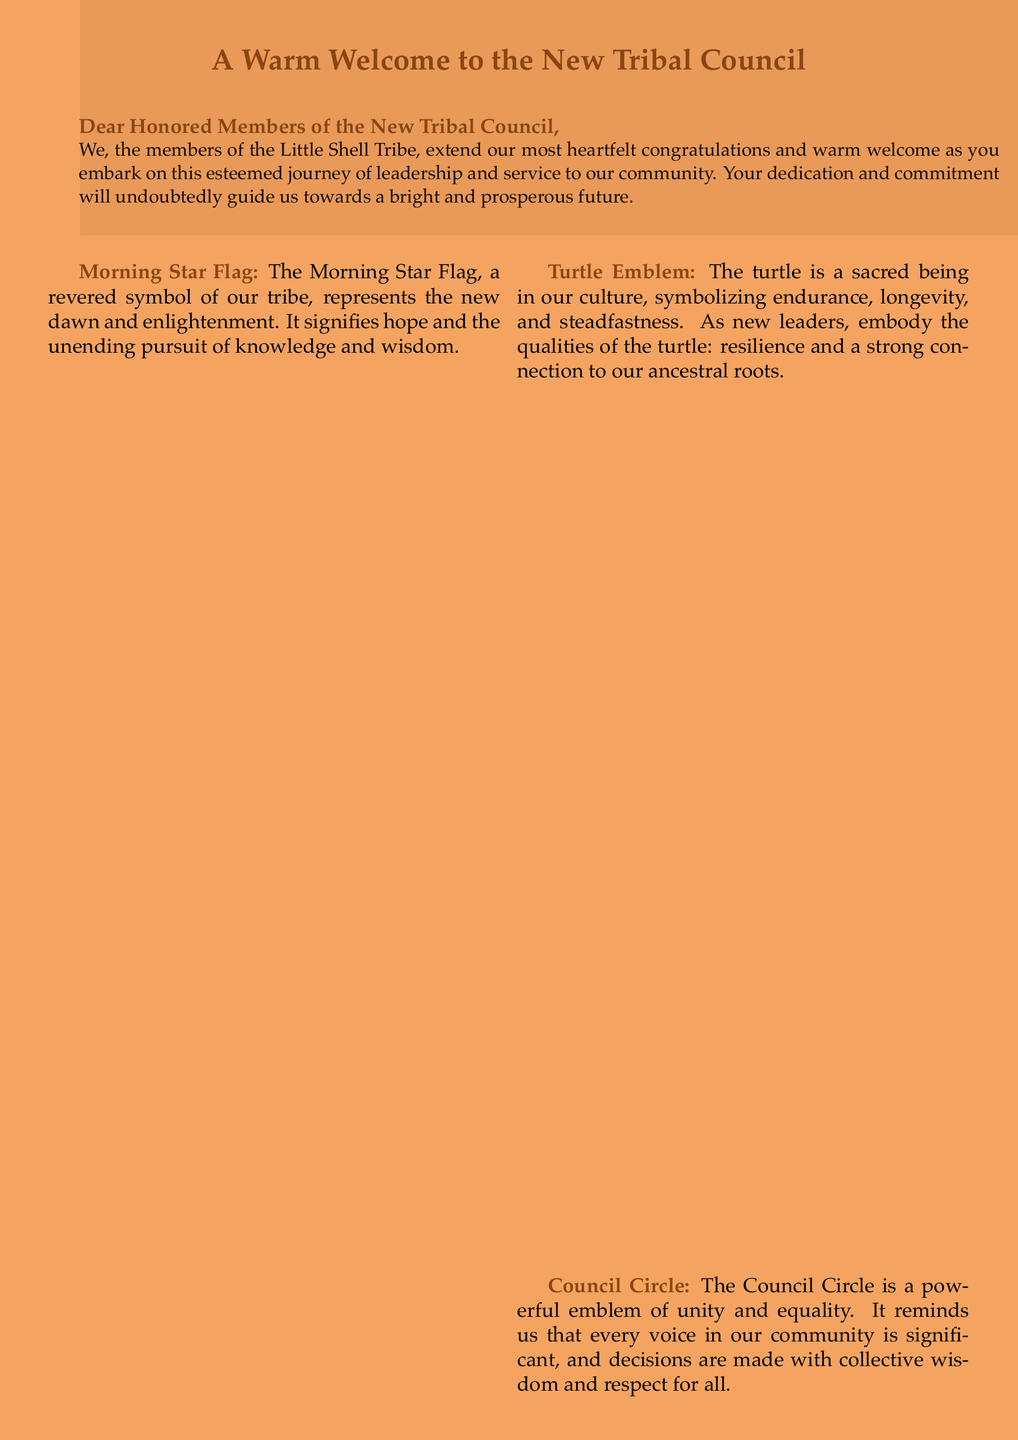What is the title of the greeting card? The title is prominently displayed at the top of the document, welcoming the new council.
Answer: A Warm Welcome to the New Tribal Council Who is the message addressed to? The greeting card specifically addresses the new leaders, referring to them as honored members.
Answer: Honored Members of the New Tribal Council What is the color of the page background? The background color is mentioned in the document, enhancing the visual design.
Answer: Sandcolor What does the Morning Star Flag symbolize? The document describes the symbolism of the Morning Star Flag in relation to hope and enlightenment.
Answer: New dawn and enlightenment What qualities should the new leaders embody according to the turtle emblem? The turtle emblem conveys specific characteristics that new leaders should aspire to reflect.
Answer: Resilience and a strong connection to our ancestral roots What is the primary theme of the greeting card? The overall theme conveys encouragement and support for the new council's journey.
Answer: Congratulations and warm welcome What does the feather of Chief Little Shell represent? The meaning of the feather is given within the text, highlighting its significance for leadership.
Answer: Authority, responsibility, and the guiding spirit How is the Council Circle described? The description of the Council Circle highlights its importance in the tribe's governance.
Answer: A powerful emblem of unity and equality 